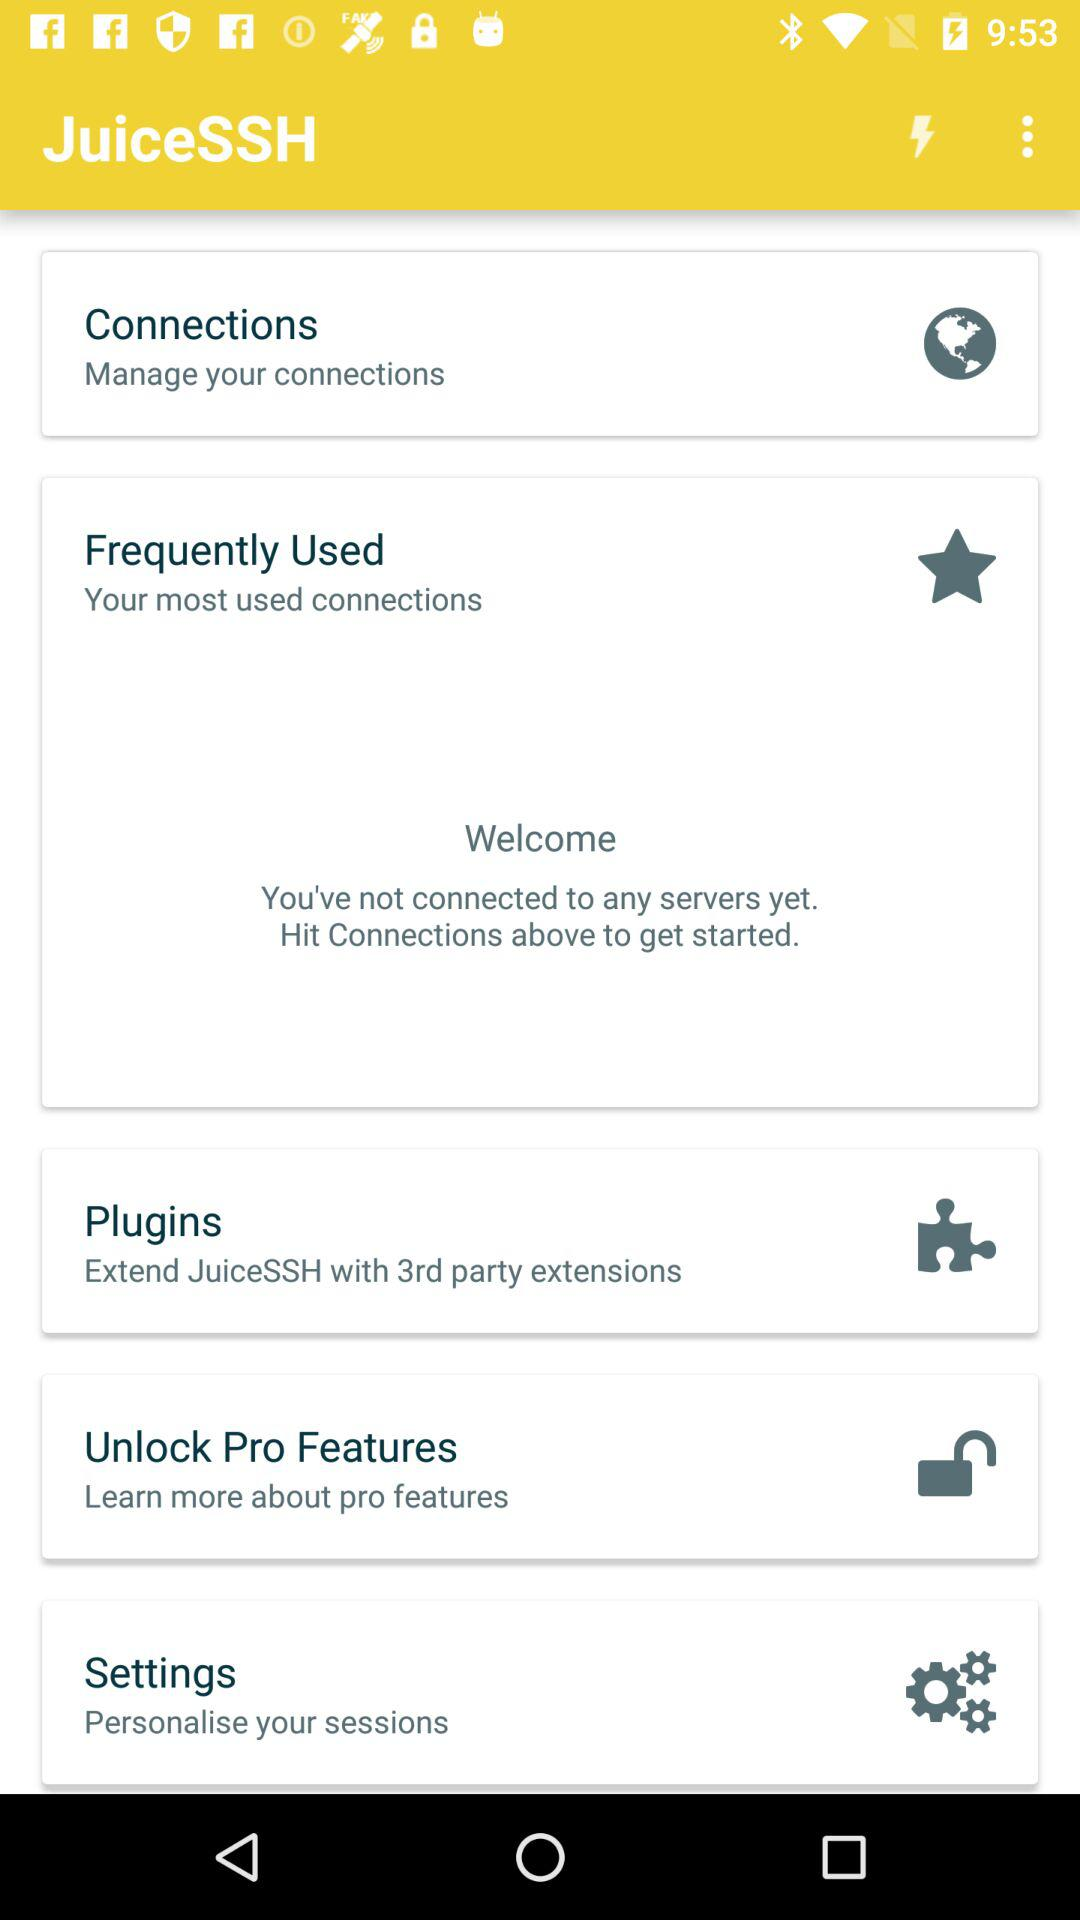What is the application name? The application name is "JuiceSSH". 